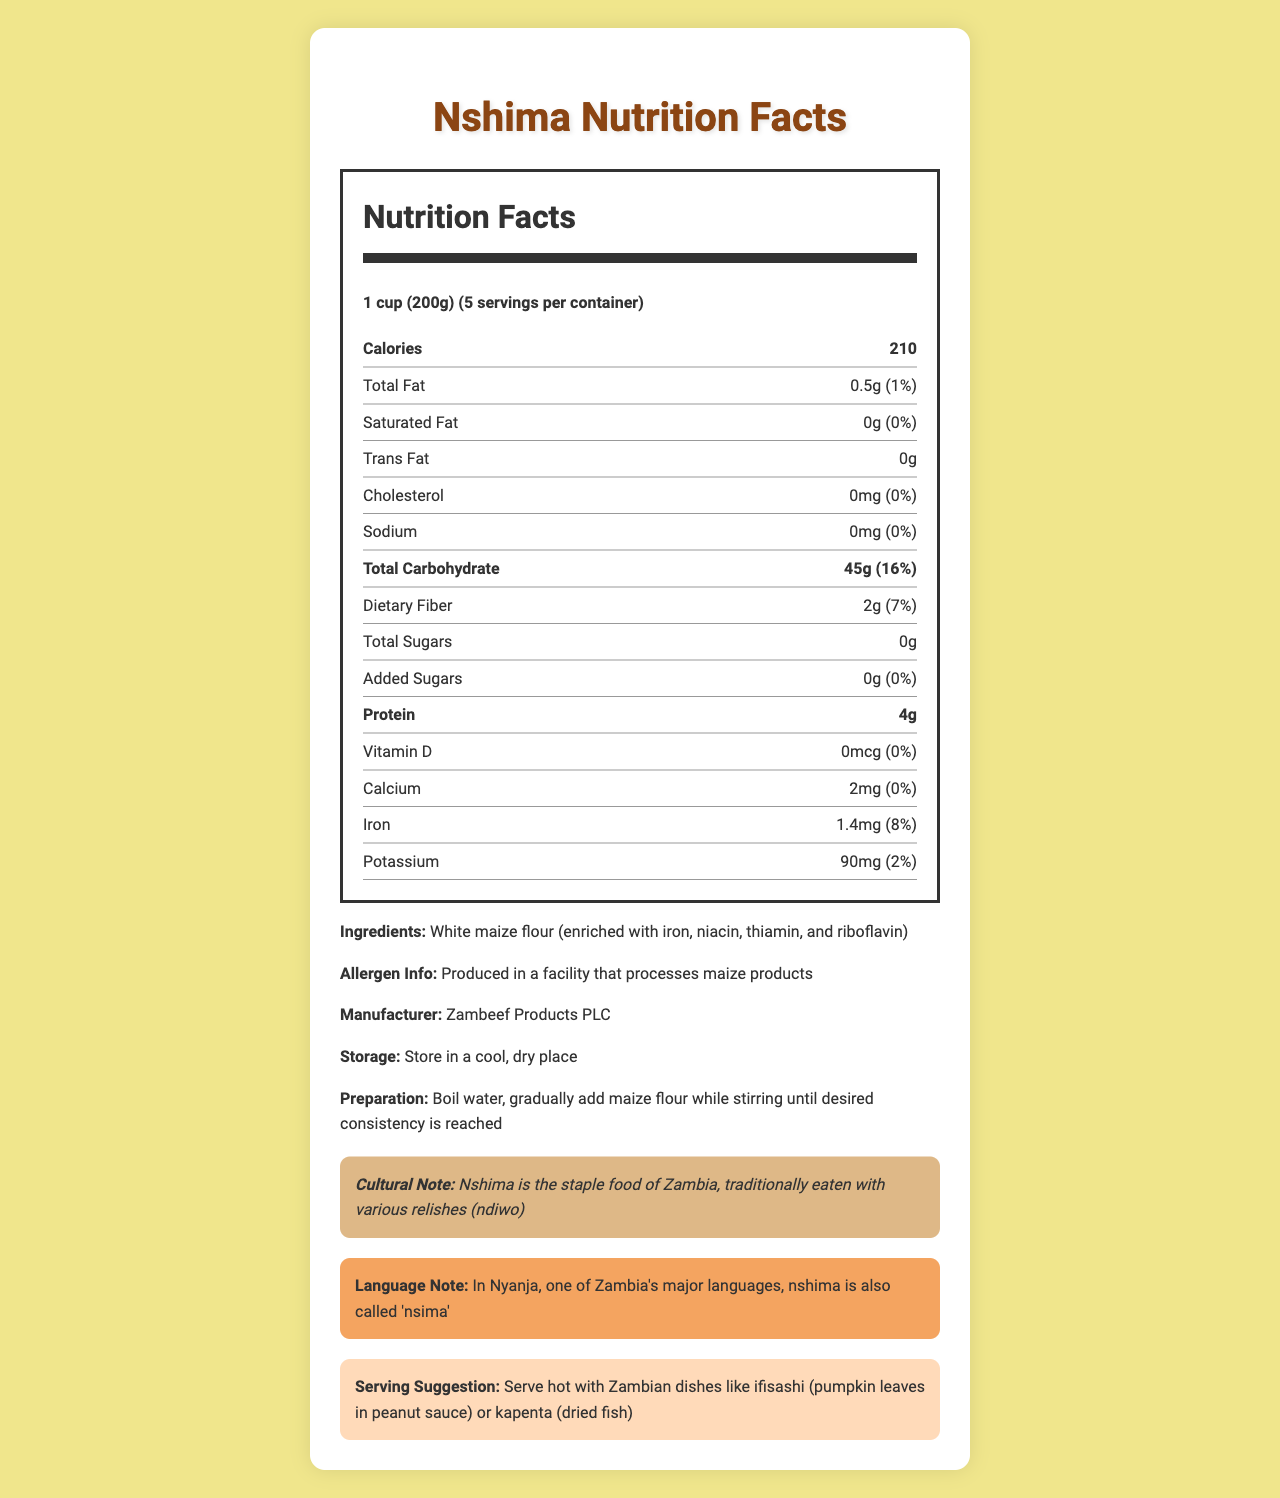What is the serving size for nshima? The serving size is clearly mentioned at the top of the Nutrition Facts section as 1 cup (200g).
Answer: 1 cup (200g) How many servings per container are there? The document states that there are 5 servings per container.
Answer: 5 What is the total amount of protein per serving of nshima? The amount of protein is listed as 4g per serving in the nutrition facts.
Answer: 4g Is there any cholesterol in nshima? The Nutrition Facts label indicates that there is 0mg of cholesterol and 0% daily value.
Answer: No What is the daily value percentage of dietary fiber in nshima? The daily value percentage for dietary fiber is stated as 7%.
Answer: 7% How many calories are in one serving of nshima? The document lists 210 calories per serving.
Answer: 210 What is the main ingredient in nshima? The ingredient list specifies that white maize flour is the main ingredient, with added enrichments.
Answer: White maize flour (enriched with iron, niacin, thiamin, and riboflavin) How should nshima be stored? The storage instructions advise to store the product in a cool, dry place.
Answer: Store in a cool, dry place How should nshima be prepared? The preparation instructions indicate to add maize flour gradually to boiling water while stirring.
Answer: Boil water, gradually add maize flour while stirring until desired consistency is reached What percentage of daily value is the total carbohydrate in nshima? The total carbohydrate daily value percentage is listed as 16%.
Answer: 16% Which vitamin is not present in nshima? The Nutrition Facts indicate that Vitamin D is 0mcg with a daily value of 0%.
Answer: Vitamin D What is the amount of trans fat in nshima? The trans fat amount is listed as 0g.
Answer: 0g How much calcium is present in a serving of nshima? The document states that there are 2mg of calcium per serving.
Answer: 2mg What cultural note is given about nshima? A. It is a type of soup B. It is a staple food of Zambia C. It is a popular dessert The nutrition label contains a cultural note stating that nshima is the staple food of Zambia.
Answer: B What is the primary manufacturer of nshima? A. Tiger Products PLC B. Zambeef Products PLC C. MaizeCorp PLC The label mentions Zambeef Products PLC as the manufacturer.
Answer: B Does nshima contain any added sugars? The added sugars amount is listed as 0g, with a daily value of 0%.
Answer: No What is the serving suggestion for nshima? The serving suggestion describes serving nshima with typical Zambian dishes like ifisashi or kapenta.
Answer: Serve hot with Zambian dishes like ifisashi (pumpkin leaves in peanut sauce) or kapenta (dried fish) What is nshima called in Nyanja? The language note states that in Nyanja, nshima is also called 'nsima'.
Answer: Nsima How much iron is present in a serving of nshima, and what is its daily value percentage? The document lists iron content as 1.4mg with a daily value percentage of 8%.
Answer: 1.4mg, 8% What type of product is nshima considered based on the nutritional claim? The nutritional claim specifies that nshima is low in fat and sugar and a good source of complex carbohydrates.
Answer: Low in fat and sugar, good source of complex carbohydrates Can the preparation of nshima be determined by looking at the ingredients only? The preparation involves a specific process (boiling water and adding maize flour) which is not evident from the ingredients list alone.
Answer: Cannot be determined Summarize the main information provided in the document. The document outlines nutrition facts, ingredient details, preparation methods, manufacturer information, and cultural notes related to nshima. It emphasizes its role as a staple food in Zambia, highlights its low-fat and low-sugar profile, and suggests traditional ways to serve it.
Answer: The document provides detailed nutritional information about nshima, a traditional Zambian staple food made from maize flour. It includes serving size, nutritional values, ingredients, manufacturer, storage and preparation instructions, cultural and language notes, and serving suggestions. Nshima is low in fat and sugar and a good source of complex carbohydrates. 